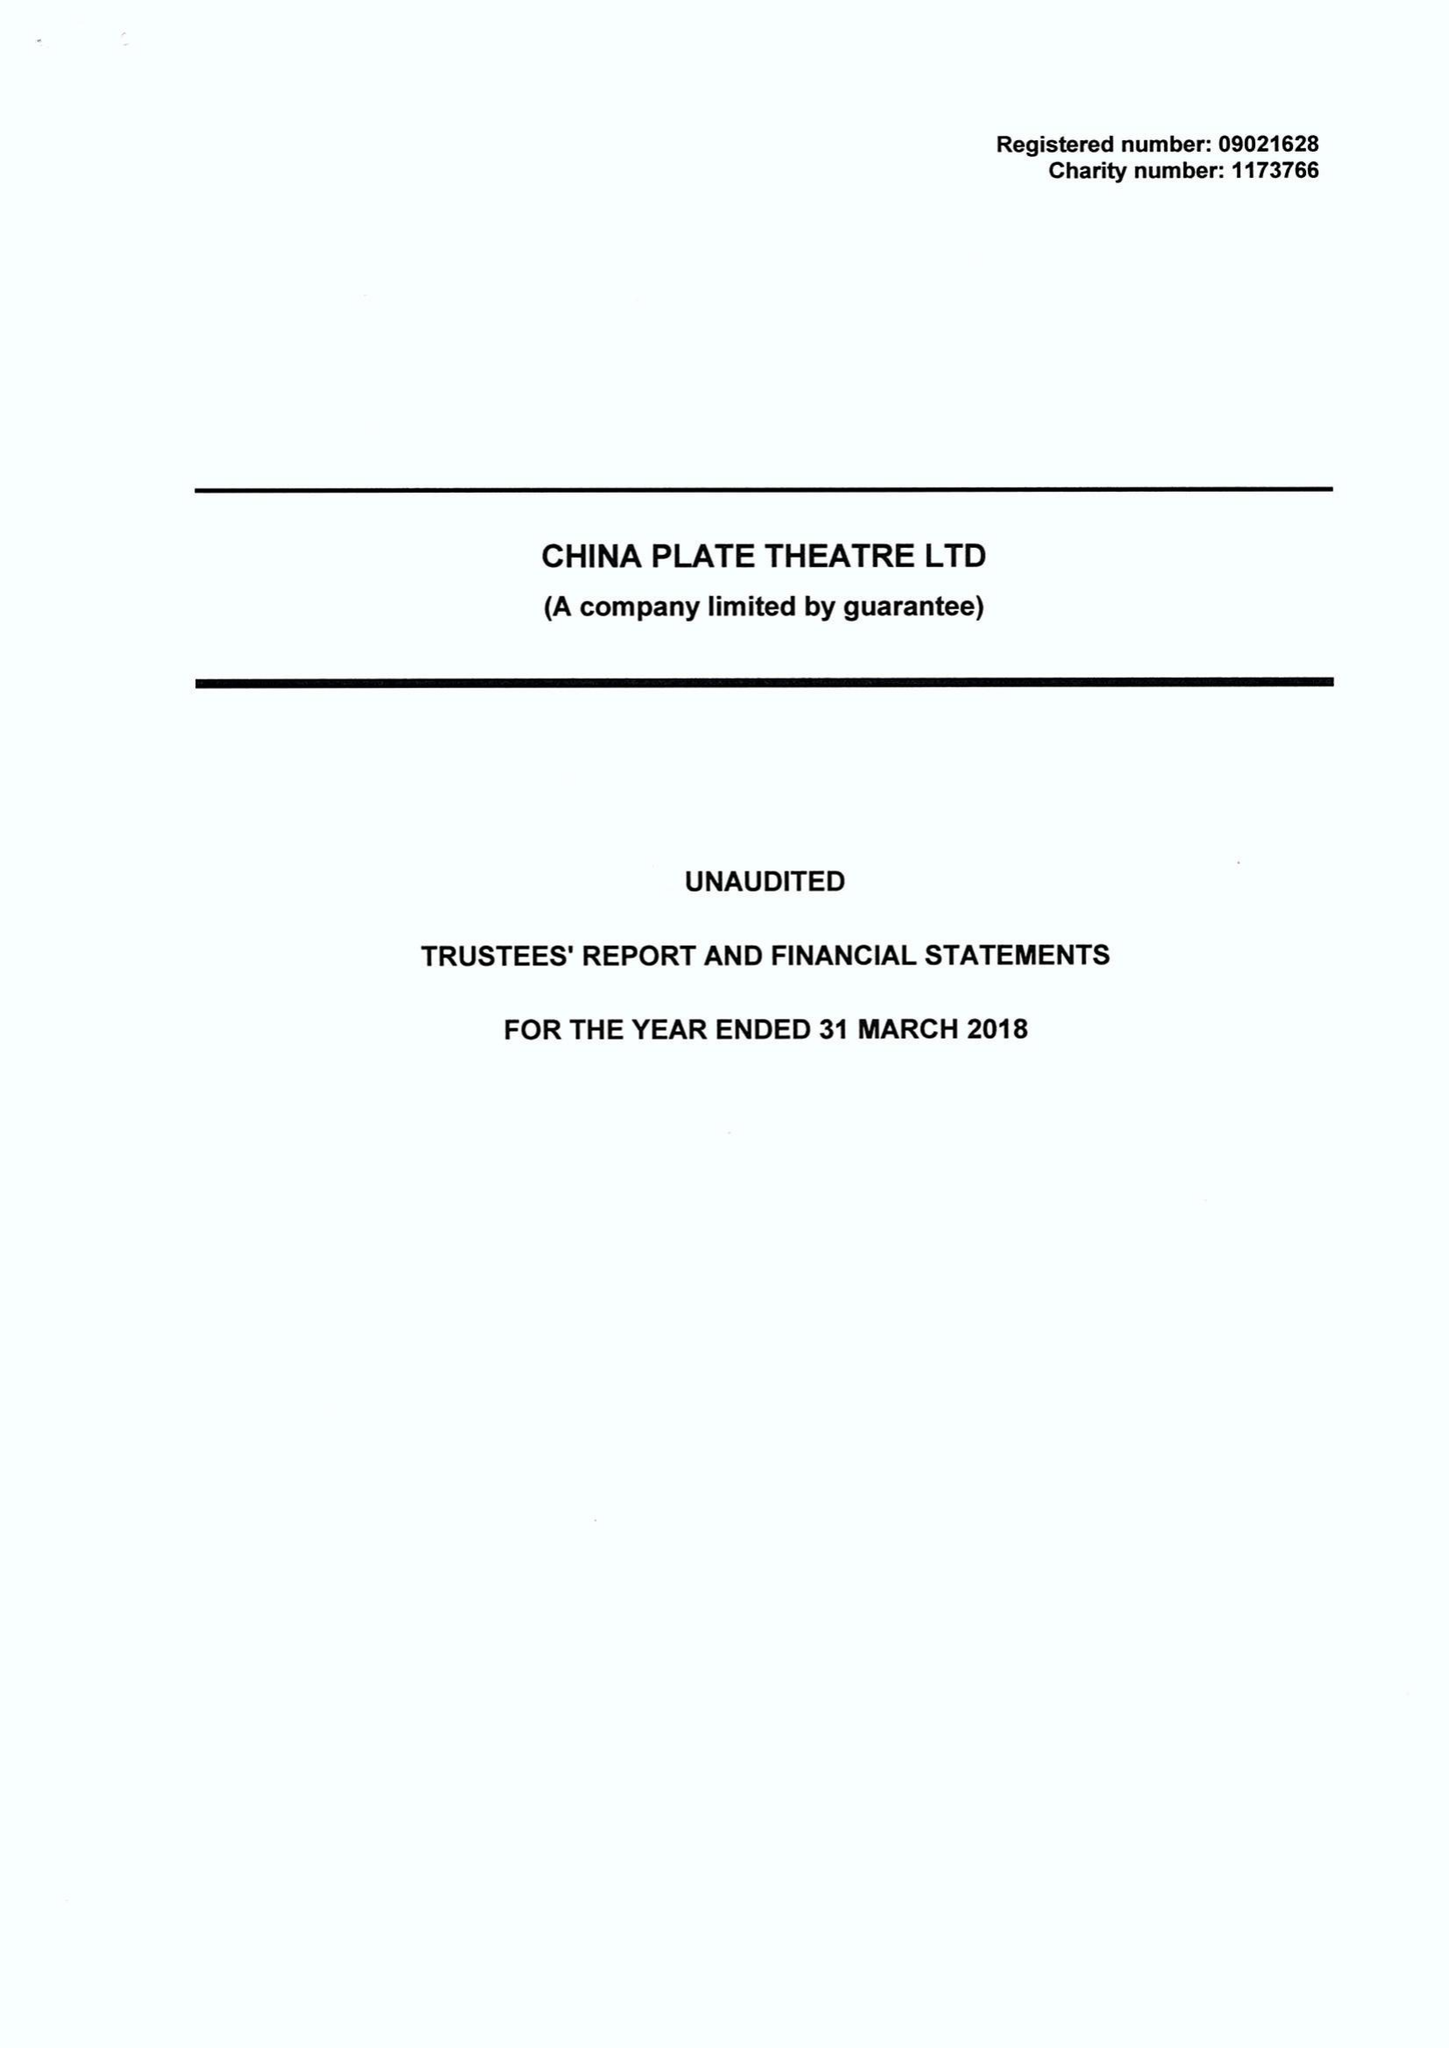What is the value for the report_date?
Answer the question using a single word or phrase. 2018-03-31 